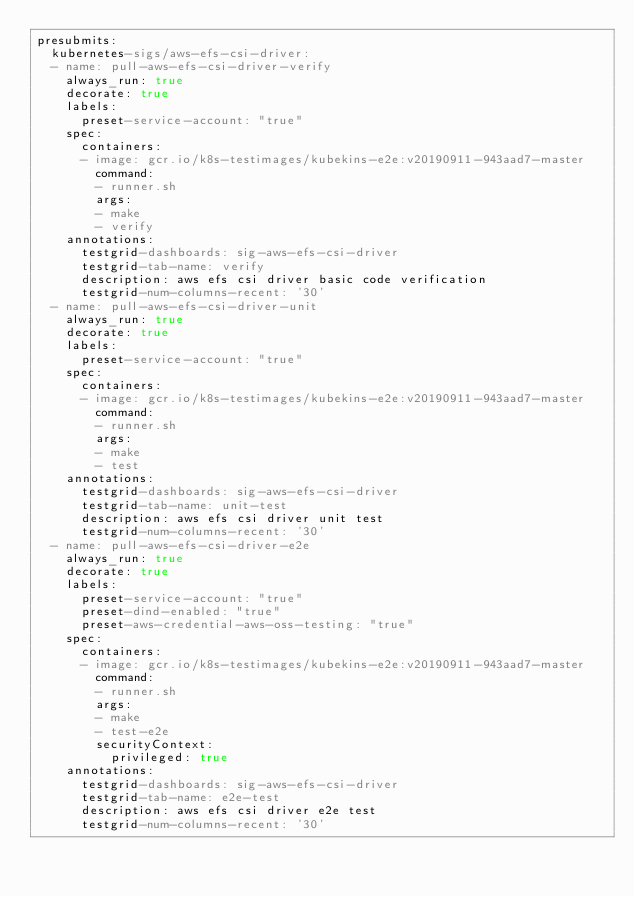Convert code to text. <code><loc_0><loc_0><loc_500><loc_500><_YAML_>presubmits:
  kubernetes-sigs/aws-efs-csi-driver:
  - name: pull-aws-efs-csi-driver-verify
    always_run: true
    decorate: true
    labels:
      preset-service-account: "true"
    spec:
      containers:
      - image: gcr.io/k8s-testimages/kubekins-e2e:v20190911-943aad7-master
        command:
        - runner.sh
        args:
        - make
        - verify
    annotations:
      testgrid-dashboards: sig-aws-efs-csi-driver
      testgrid-tab-name: verify
      description: aws efs csi driver basic code verification
      testgrid-num-columns-recent: '30'
  - name: pull-aws-efs-csi-driver-unit
    always_run: true
    decorate: true
    labels:
      preset-service-account: "true"
    spec:
      containers:
      - image: gcr.io/k8s-testimages/kubekins-e2e:v20190911-943aad7-master
        command:
        - runner.sh
        args:
        - make
        - test
    annotations:
      testgrid-dashboards: sig-aws-efs-csi-driver
      testgrid-tab-name: unit-test
      description: aws efs csi driver unit test
      testgrid-num-columns-recent: '30'
  - name: pull-aws-efs-csi-driver-e2e
    always_run: true
    decorate: true
    labels:
      preset-service-account: "true"
      preset-dind-enabled: "true"
      preset-aws-credential-aws-oss-testing: "true"
    spec:
      containers:
      - image: gcr.io/k8s-testimages/kubekins-e2e:v20190911-943aad7-master
        command:
        - runner.sh
        args:
        - make
        - test-e2e
        securityContext:
          privileged: true
    annotations:
      testgrid-dashboards: sig-aws-efs-csi-driver
      testgrid-tab-name: e2e-test
      description: aws efs csi driver e2e test
      testgrid-num-columns-recent: '30'
</code> 